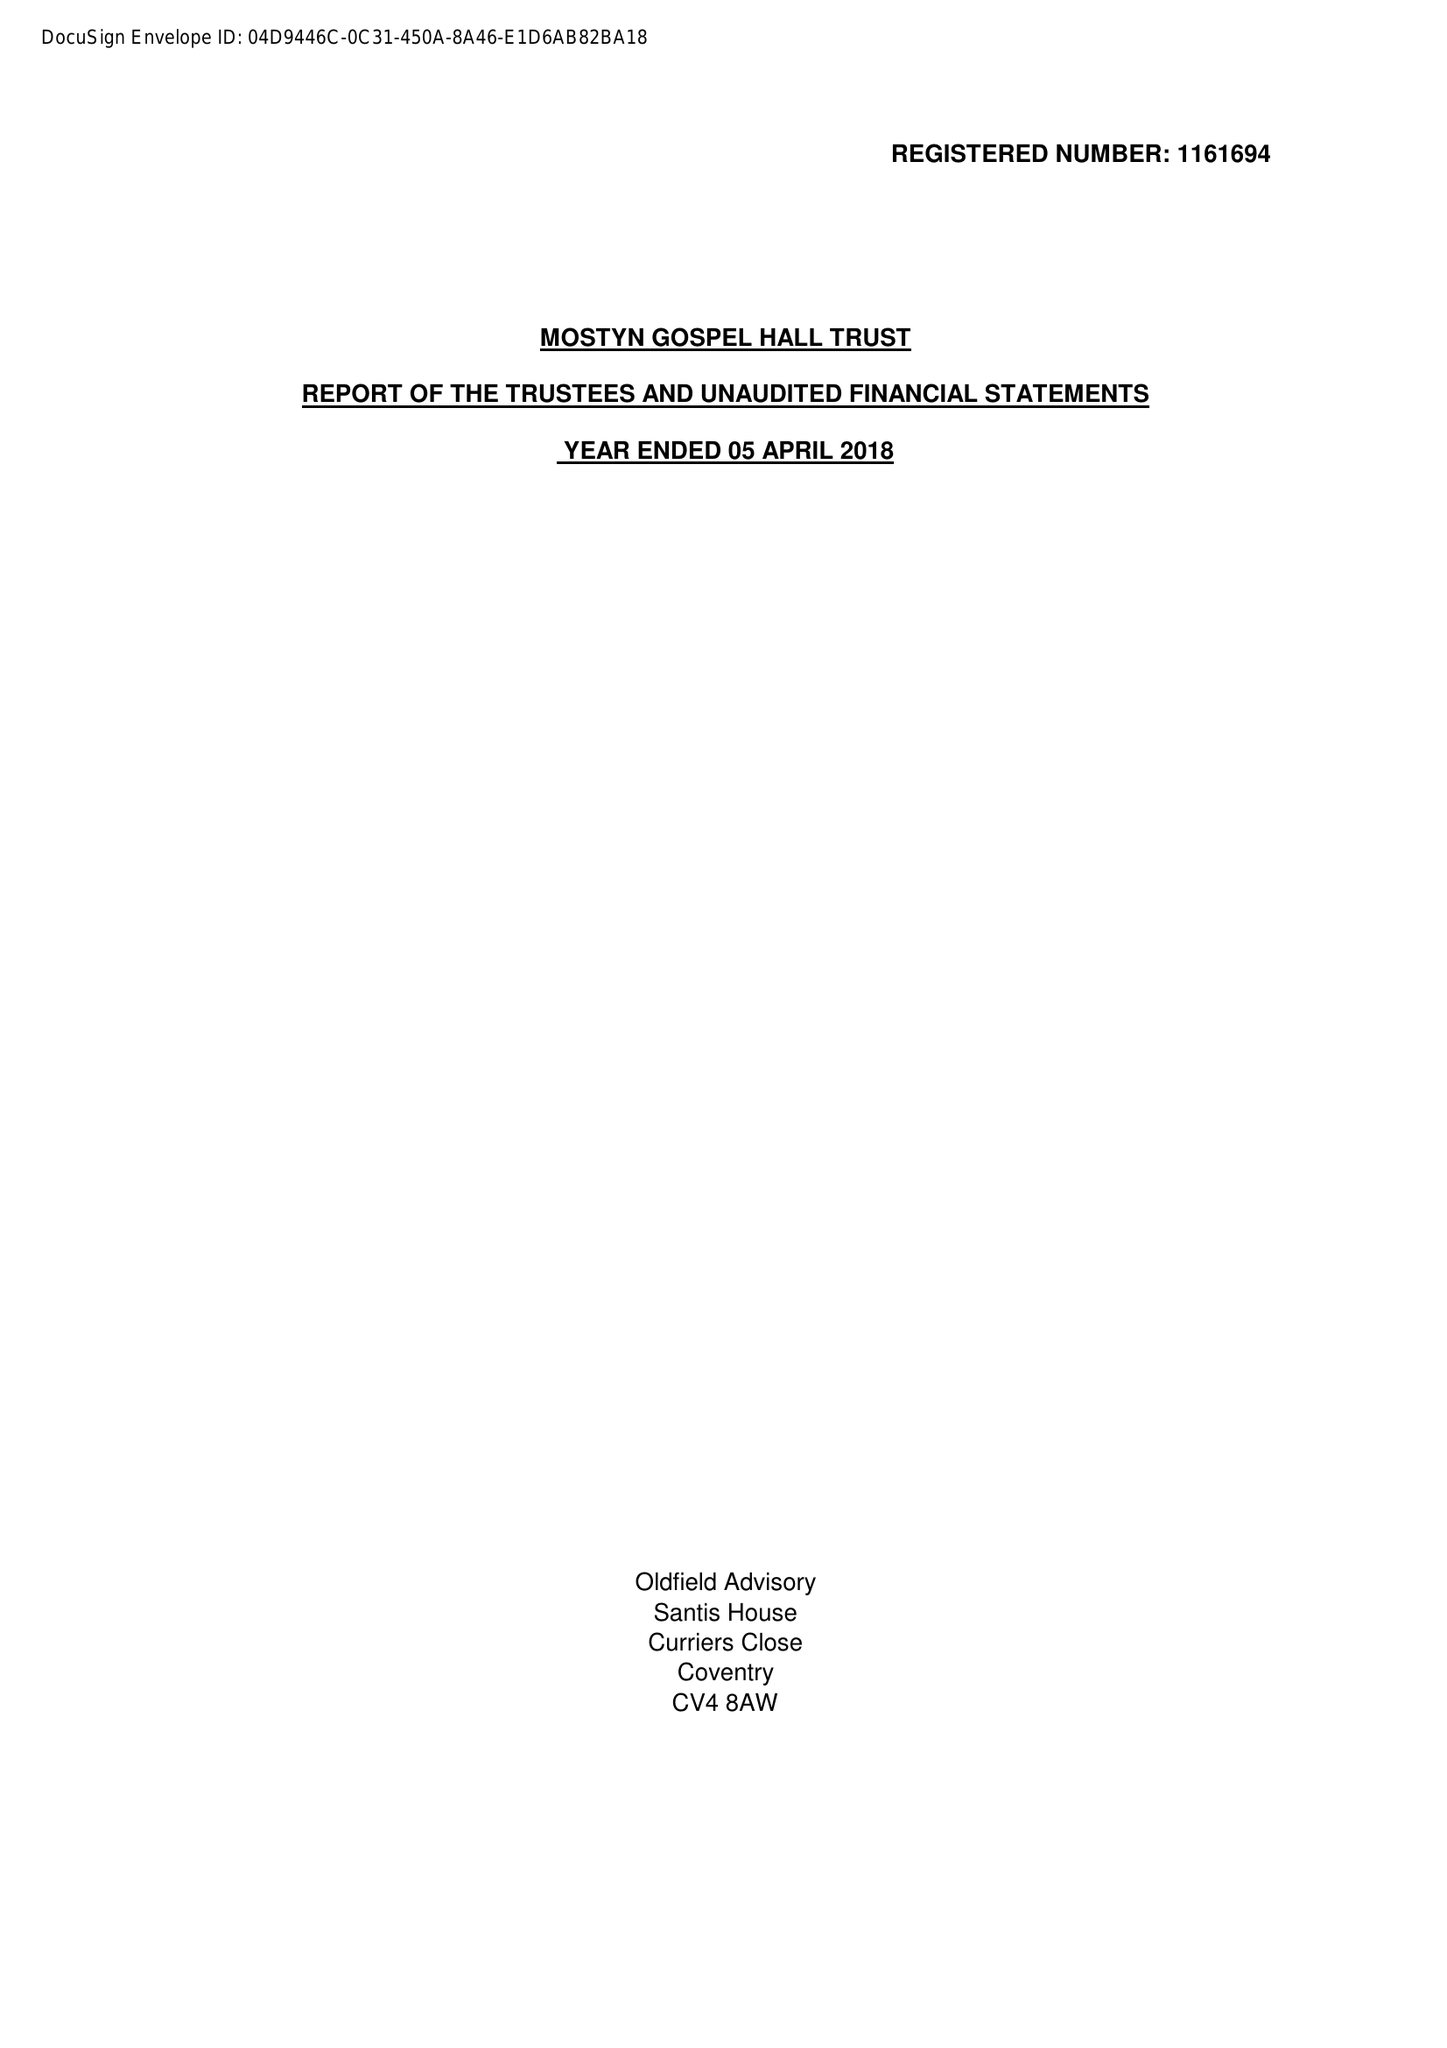What is the value for the charity_name?
Answer the question using a single word or phrase. Mostyn Gospel Hall Trust 